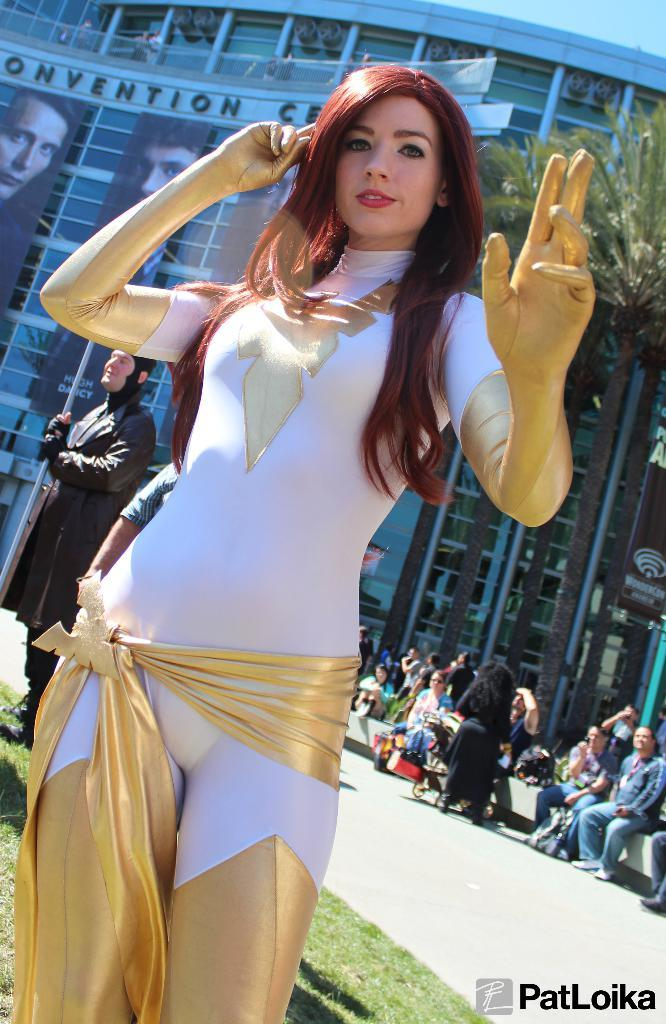What is the woman in the image wearing? The woman in the image is wearing a white and gold dress. Where are the people in the image located? The people in the image are sitting on a bench towards the right side of the image. What can be seen in the background of the image? There is a building and a tree in the background of the image. What type of badge is the woman wearing in the image? The woman in the image is not wearing a badge; she is wearing a white and gold dress. Can you see the woman's pet in the image? There is no pet visible in the image. 